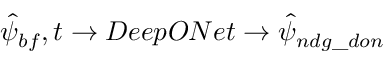Convert formula to latex. <formula><loc_0><loc_0><loc_500><loc_500>\hat { \psi } _ { b f } , t \rightarrow D e e p O N e t \rightarrow \hat { \psi } _ { n d g \_ d o n }</formula> 